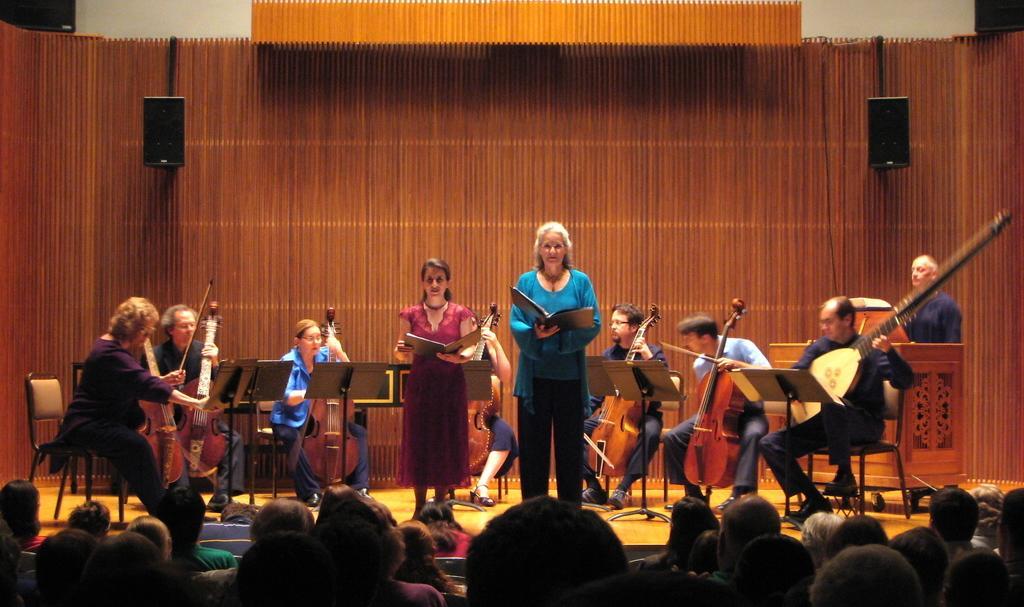Describe this image in one or two sentences. In this picture there are two persons standing and holding the books and there are group of people sitting and holding the musical instruments and there are stands. In the foreground there are group of people sitting. At the back there are speakers on the wall and there is a person standing behind the podium. 